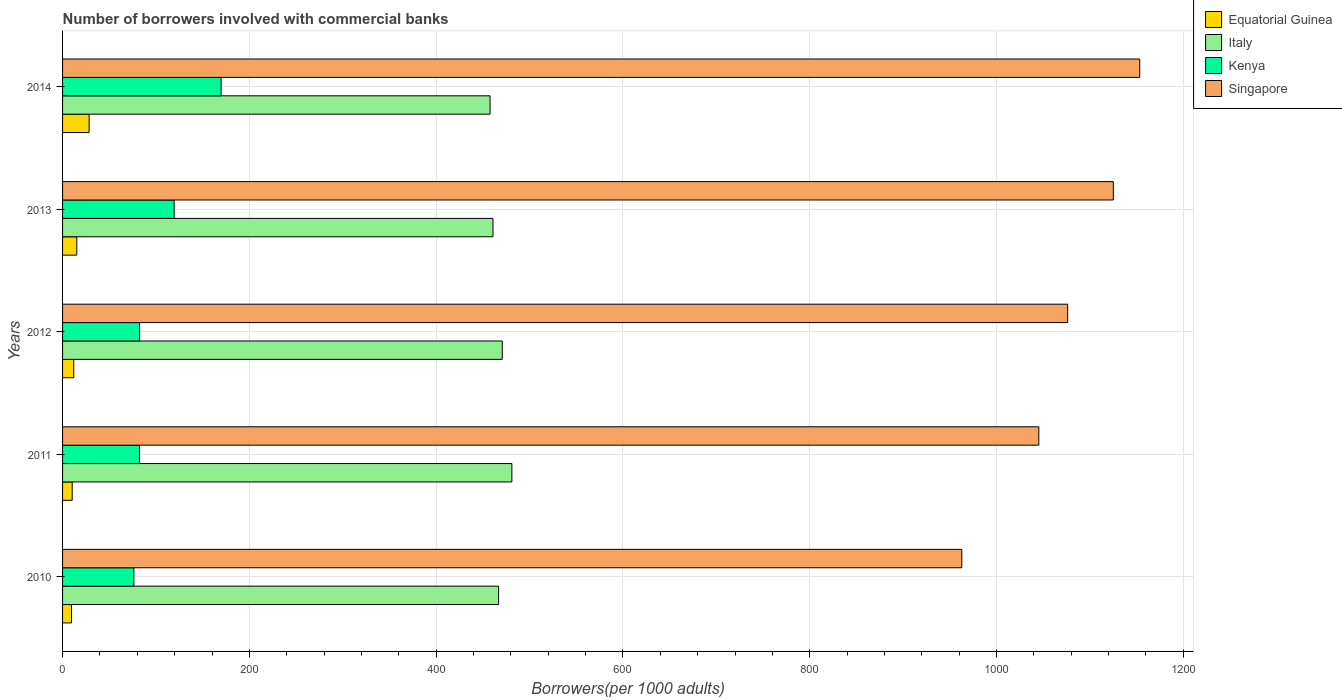How many different coloured bars are there?
Make the answer very short. 4. Are the number of bars per tick equal to the number of legend labels?
Keep it short and to the point. Yes. Are the number of bars on each tick of the Y-axis equal?
Provide a succinct answer. Yes. What is the number of borrowers involved with commercial banks in Singapore in 2014?
Offer a very short reply. 1153.3. Across all years, what is the maximum number of borrowers involved with commercial banks in Italy?
Give a very brief answer. 481.07. Across all years, what is the minimum number of borrowers involved with commercial banks in Italy?
Offer a terse response. 457.72. What is the total number of borrowers involved with commercial banks in Kenya in the graph?
Offer a very short reply. 530.31. What is the difference between the number of borrowers involved with commercial banks in Kenya in 2010 and that in 2014?
Offer a very short reply. -93.39. What is the difference between the number of borrowers involved with commercial banks in Kenya in 2014 and the number of borrowers involved with commercial banks in Italy in 2013?
Ensure brevity in your answer.  -291.11. What is the average number of borrowers involved with commercial banks in Equatorial Guinea per year?
Ensure brevity in your answer.  15.11. In the year 2014, what is the difference between the number of borrowers involved with commercial banks in Equatorial Guinea and number of borrowers involved with commercial banks in Kenya?
Offer a very short reply. -141.3. In how many years, is the number of borrowers involved with commercial banks in Italy greater than 920 ?
Keep it short and to the point. 0. What is the ratio of the number of borrowers involved with commercial banks in Equatorial Guinea in 2012 to that in 2014?
Your answer should be compact. 0.42. Is the difference between the number of borrowers involved with commercial banks in Equatorial Guinea in 2010 and 2012 greater than the difference between the number of borrowers involved with commercial banks in Kenya in 2010 and 2012?
Provide a short and direct response. Yes. What is the difference between the highest and the second highest number of borrowers involved with commercial banks in Italy?
Make the answer very short. 10.28. What is the difference between the highest and the lowest number of borrowers involved with commercial banks in Singapore?
Offer a terse response. 190.51. Is it the case that in every year, the sum of the number of borrowers involved with commercial banks in Equatorial Guinea and number of borrowers involved with commercial banks in Italy is greater than the sum of number of borrowers involved with commercial banks in Singapore and number of borrowers involved with commercial banks in Kenya?
Provide a short and direct response. Yes. What does the 2nd bar from the top in 2012 represents?
Provide a succinct answer. Kenya. What does the 2nd bar from the bottom in 2014 represents?
Provide a succinct answer. Italy. Is it the case that in every year, the sum of the number of borrowers involved with commercial banks in Kenya and number of borrowers involved with commercial banks in Singapore is greater than the number of borrowers involved with commercial banks in Equatorial Guinea?
Your response must be concise. Yes. How many bars are there?
Give a very brief answer. 20. How many years are there in the graph?
Provide a short and direct response. 5. What is the difference between two consecutive major ticks on the X-axis?
Make the answer very short. 200. Does the graph contain any zero values?
Keep it short and to the point. No. Does the graph contain grids?
Keep it short and to the point. Yes. How many legend labels are there?
Provide a succinct answer. 4. How are the legend labels stacked?
Your answer should be compact. Vertical. What is the title of the graph?
Keep it short and to the point. Number of borrowers involved with commercial banks. What is the label or title of the X-axis?
Provide a succinct answer. Borrowers(per 1000 adults). What is the Borrowers(per 1000 adults) of Equatorial Guinea in 2010?
Your answer should be compact. 9.58. What is the Borrowers(per 1000 adults) in Italy in 2010?
Your answer should be very brief. 466.85. What is the Borrowers(per 1000 adults) of Kenya in 2010?
Offer a very short reply. 76.34. What is the Borrowers(per 1000 adults) in Singapore in 2010?
Offer a terse response. 962.8. What is the Borrowers(per 1000 adults) of Equatorial Guinea in 2011?
Make the answer very short. 10.32. What is the Borrowers(per 1000 adults) of Italy in 2011?
Offer a terse response. 481.07. What is the Borrowers(per 1000 adults) of Kenya in 2011?
Make the answer very short. 82.34. What is the Borrowers(per 1000 adults) of Singapore in 2011?
Your answer should be very brief. 1045.25. What is the Borrowers(per 1000 adults) of Equatorial Guinea in 2012?
Provide a short and direct response. 11.98. What is the Borrowers(per 1000 adults) of Italy in 2012?
Offer a terse response. 470.79. What is the Borrowers(per 1000 adults) of Kenya in 2012?
Offer a very short reply. 82.45. What is the Borrowers(per 1000 adults) of Singapore in 2012?
Your answer should be very brief. 1076.16. What is the Borrowers(per 1000 adults) of Equatorial Guinea in 2013?
Your response must be concise. 15.22. What is the Borrowers(per 1000 adults) in Italy in 2013?
Provide a succinct answer. 460.84. What is the Borrowers(per 1000 adults) of Kenya in 2013?
Provide a short and direct response. 119.46. What is the Borrowers(per 1000 adults) in Singapore in 2013?
Keep it short and to the point. 1125.04. What is the Borrowers(per 1000 adults) in Equatorial Guinea in 2014?
Offer a terse response. 28.43. What is the Borrowers(per 1000 adults) of Italy in 2014?
Provide a succinct answer. 457.72. What is the Borrowers(per 1000 adults) in Kenya in 2014?
Provide a short and direct response. 169.73. What is the Borrowers(per 1000 adults) in Singapore in 2014?
Offer a terse response. 1153.3. Across all years, what is the maximum Borrowers(per 1000 adults) of Equatorial Guinea?
Make the answer very short. 28.43. Across all years, what is the maximum Borrowers(per 1000 adults) in Italy?
Provide a short and direct response. 481.07. Across all years, what is the maximum Borrowers(per 1000 adults) of Kenya?
Keep it short and to the point. 169.73. Across all years, what is the maximum Borrowers(per 1000 adults) of Singapore?
Give a very brief answer. 1153.3. Across all years, what is the minimum Borrowers(per 1000 adults) of Equatorial Guinea?
Make the answer very short. 9.58. Across all years, what is the minimum Borrowers(per 1000 adults) of Italy?
Your answer should be very brief. 457.72. Across all years, what is the minimum Borrowers(per 1000 adults) in Kenya?
Your answer should be compact. 76.34. Across all years, what is the minimum Borrowers(per 1000 adults) of Singapore?
Provide a short and direct response. 962.8. What is the total Borrowers(per 1000 adults) of Equatorial Guinea in the graph?
Ensure brevity in your answer.  75.53. What is the total Borrowers(per 1000 adults) of Italy in the graph?
Offer a very short reply. 2337.27. What is the total Borrowers(per 1000 adults) of Kenya in the graph?
Your response must be concise. 530.31. What is the total Borrowers(per 1000 adults) in Singapore in the graph?
Your answer should be very brief. 5362.55. What is the difference between the Borrowers(per 1000 adults) in Equatorial Guinea in 2010 and that in 2011?
Your response must be concise. -0.74. What is the difference between the Borrowers(per 1000 adults) in Italy in 2010 and that in 2011?
Your answer should be very brief. -14.22. What is the difference between the Borrowers(per 1000 adults) of Kenya in 2010 and that in 2011?
Your answer should be very brief. -6. What is the difference between the Borrowers(per 1000 adults) of Singapore in 2010 and that in 2011?
Make the answer very short. -82.46. What is the difference between the Borrowers(per 1000 adults) of Equatorial Guinea in 2010 and that in 2012?
Offer a terse response. -2.41. What is the difference between the Borrowers(per 1000 adults) in Italy in 2010 and that in 2012?
Offer a terse response. -3.94. What is the difference between the Borrowers(per 1000 adults) of Kenya in 2010 and that in 2012?
Offer a very short reply. -6.11. What is the difference between the Borrowers(per 1000 adults) of Singapore in 2010 and that in 2012?
Make the answer very short. -113.36. What is the difference between the Borrowers(per 1000 adults) in Equatorial Guinea in 2010 and that in 2013?
Offer a terse response. -5.64. What is the difference between the Borrowers(per 1000 adults) in Italy in 2010 and that in 2013?
Keep it short and to the point. 6.01. What is the difference between the Borrowers(per 1000 adults) of Kenya in 2010 and that in 2013?
Your answer should be compact. -43.12. What is the difference between the Borrowers(per 1000 adults) of Singapore in 2010 and that in 2013?
Your answer should be very brief. -162.25. What is the difference between the Borrowers(per 1000 adults) of Equatorial Guinea in 2010 and that in 2014?
Keep it short and to the point. -18.86. What is the difference between the Borrowers(per 1000 adults) in Italy in 2010 and that in 2014?
Provide a succinct answer. 9.13. What is the difference between the Borrowers(per 1000 adults) in Kenya in 2010 and that in 2014?
Provide a succinct answer. -93.39. What is the difference between the Borrowers(per 1000 adults) in Singapore in 2010 and that in 2014?
Your response must be concise. -190.51. What is the difference between the Borrowers(per 1000 adults) of Equatorial Guinea in 2011 and that in 2012?
Provide a succinct answer. -1.67. What is the difference between the Borrowers(per 1000 adults) of Italy in 2011 and that in 2012?
Ensure brevity in your answer.  10.28. What is the difference between the Borrowers(per 1000 adults) in Kenya in 2011 and that in 2012?
Keep it short and to the point. -0.11. What is the difference between the Borrowers(per 1000 adults) in Singapore in 2011 and that in 2012?
Your response must be concise. -30.9. What is the difference between the Borrowers(per 1000 adults) in Equatorial Guinea in 2011 and that in 2013?
Provide a short and direct response. -4.9. What is the difference between the Borrowers(per 1000 adults) of Italy in 2011 and that in 2013?
Keep it short and to the point. 20.23. What is the difference between the Borrowers(per 1000 adults) of Kenya in 2011 and that in 2013?
Give a very brief answer. -37.12. What is the difference between the Borrowers(per 1000 adults) in Singapore in 2011 and that in 2013?
Keep it short and to the point. -79.79. What is the difference between the Borrowers(per 1000 adults) of Equatorial Guinea in 2011 and that in 2014?
Provide a short and direct response. -18.12. What is the difference between the Borrowers(per 1000 adults) in Italy in 2011 and that in 2014?
Offer a very short reply. 23.35. What is the difference between the Borrowers(per 1000 adults) in Kenya in 2011 and that in 2014?
Provide a succinct answer. -87.39. What is the difference between the Borrowers(per 1000 adults) in Singapore in 2011 and that in 2014?
Offer a terse response. -108.05. What is the difference between the Borrowers(per 1000 adults) of Equatorial Guinea in 2012 and that in 2013?
Your answer should be compact. -3.23. What is the difference between the Borrowers(per 1000 adults) of Italy in 2012 and that in 2013?
Offer a very short reply. 9.95. What is the difference between the Borrowers(per 1000 adults) in Kenya in 2012 and that in 2013?
Make the answer very short. -37.01. What is the difference between the Borrowers(per 1000 adults) of Singapore in 2012 and that in 2013?
Provide a short and direct response. -48.89. What is the difference between the Borrowers(per 1000 adults) in Equatorial Guinea in 2012 and that in 2014?
Provide a short and direct response. -16.45. What is the difference between the Borrowers(per 1000 adults) in Italy in 2012 and that in 2014?
Offer a very short reply. 13.07. What is the difference between the Borrowers(per 1000 adults) in Kenya in 2012 and that in 2014?
Ensure brevity in your answer.  -87.28. What is the difference between the Borrowers(per 1000 adults) in Singapore in 2012 and that in 2014?
Ensure brevity in your answer.  -77.15. What is the difference between the Borrowers(per 1000 adults) in Equatorial Guinea in 2013 and that in 2014?
Provide a short and direct response. -13.22. What is the difference between the Borrowers(per 1000 adults) of Italy in 2013 and that in 2014?
Keep it short and to the point. 3.12. What is the difference between the Borrowers(per 1000 adults) of Kenya in 2013 and that in 2014?
Keep it short and to the point. -50.27. What is the difference between the Borrowers(per 1000 adults) of Singapore in 2013 and that in 2014?
Give a very brief answer. -28.26. What is the difference between the Borrowers(per 1000 adults) of Equatorial Guinea in 2010 and the Borrowers(per 1000 adults) of Italy in 2011?
Provide a short and direct response. -471.49. What is the difference between the Borrowers(per 1000 adults) of Equatorial Guinea in 2010 and the Borrowers(per 1000 adults) of Kenya in 2011?
Ensure brevity in your answer.  -72.76. What is the difference between the Borrowers(per 1000 adults) of Equatorial Guinea in 2010 and the Borrowers(per 1000 adults) of Singapore in 2011?
Ensure brevity in your answer.  -1035.67. What is the difference between the Borrowers(per 1000 adults) of Italy in 2010 and the Borrowers(per 1000 adults) of Kenya in 2011?
Offer a very short reply. 384.51. What is the difference between the Borrowers(per 1000 adults) in Italy in 2010 and the Borrowers(per 1000 adults) in Singapore in 2011?
Your answer should be compact. -578.4. What is the difference between the Borrowers(per 1000 adults) in Kenya in 2010 and the Borrowers(per 1000 adults) in Singapore in 2011?
Provide a short and direct response. -968.91. What is the difference between the Borrowers(per 1000 adults) of Equatorial Guinea in 2010 and the Borrowers(per 1000 adults) of Italy in 2012?
Keep it short and to the point. -461.21. What is the difference between the Borrowers(per 1000 adults) in Equatorial Guinea in 2010 and the Borrowers(per 1000 adults) in Kenya in 2012?
Make the answer very short. -72.87. What is the difference between the Borrowers(per 1000 adults) in Equatorial Guinea in 2010 and the Borrowers(per 1000 adults) in Singapore in 2012?
Offer a very short reply. -1066.58. What is the difference between the Borrowers(per 1000 adults) in Italy in 2010 and the Borrowers(per 1000 adults) in Kenya in 2012?
Ensure brevity in your answer.  384.4. What is the difference between the Borrowers(per 1000 adults) in Italy in 2010 and the Borrowers(per 1000 adults) in Singapore in 2012?
Offer a terse response. -609.31. What is the difference between the Borrowers(per 1000 adults) of Kenya in 2010 and the Borrowers(per 1000 adults) of Singapore in 2012?
Offer a very short reply. -999.82. What is the difference between the Borrowers(per 1000 adults) of Equatorial Guinea in 2010 and the Borrowers(per 1000 adults) of Italy in 2013?
Provide a short and direct response. -451.26. What is the difference between the Borrowers(per 1000 adults) in Equatorial Guinea in 2010 and the Borrowers(per 1000 adults) in Kenya in 2013?
Your response must be concise. -109.88. What is the difference between the Borrowers(per 1000 adults) of Equatorial Guinea in 2010 and the Borrowers(per 1000 adults) of Singapore in 2013?
Ensure brevity in your answer.  -1115.46. What is the difference between the Borrowers(per 1000 adults) of Italy in 2010 and the Borrowers(per 1000 adults) of Kenya in 2013?
Make the answer very short. 347.39. What is the difference between the Borrowers(per 1000 adults) in Italy in 2010 and the Borrowers(per 1000 adults) in Singapore in 2013?
Provide a short and direct response. -658.19. What is the difference between the Borrowers(per 1000 adults) of Kenya in 2010 and the Borrowers(per 1000 adults) of Singapore in 2013?
Provide a succinct answer. -1048.7. What is the difference between the Borrowers(per 1000 adults) in Equatorial Guinea in 2010 and the Borrowers(per 1000 adults) in Italy in 2014?
Offer a terse response. -448.15. What is the difference between the Borrowers(per 1000 adults) of Equatorial Guinea in 2010 and the Borrowers(per 1000 adults) of Kenya in 2014?
Offer a very short reply. -160.15. What is the difference between the Borrowers(per 1000 adults) in Equatorial Guinea in 2010 and the Borrowers(per 1000 adults) in Singapore in 2014?
Your answer should be compact. -1143.73. What is the difference between the Borrowers(per 1000 adults) in Italy in 2010 and the Borrowers(per 1000 adults) in Kenya in 2014?
Offer a very short reply. 297.12. What is the difference between the Borrowers(per 1000 adults) of Italy in 2010 and the Borrowers(per 1000 adults) of Singapore in 2014?
Your response must be concise. -686.45. What is the difference between the Borrowers(per 1000 adults) of Kenya in 2010 and the Borrowers(per 1000 adults) of Singapore in 2014?
Make the answer very short. -1076.96. What is the difference between the Borrowers(per 1000 adults) of Equatorial Guinea in 2011 and the Borrowers(per 1000 adults) of Italy in 2012?
Ensure brevity in your answer.  -460.47. What is the difference between the Borrowers(per 1000 adults) of Equatorial Guinea in 2011 and the Borrowers(per 1000 adults) of Kenya in 2012?
Provide a succinct answer. -72.13. What is the difference between the Borrowers(per 1000 adults) of Equatorial Guinea in 2011 and the Borrowers(per 1000 adults) of Singapore in 2012?
Keep it short and to the point. -1065.84. What is the difference between the Borrowers(per 1000 adults) in Italy in 2011 and the Borrowers(per 1000 adults) in Kenya in 2012?
Offer a very short reply. 398.62. What is the difference between the Borrowers(per 1000 adults) of Italy in 2011 and the Borrowers(per 1000 adults) of Singapore in 2012?
Provide a succinct answer. -595.09. What is the difference between the Borrowers(per 1000 adults) of Kenya in 2011 and the Borrowers(per 1000 adults) of Singapore in 2012?
Your answer should be compact. -993.82. What is the difference between the Borrowers(per 1000 adults) of Equatorial Guinea in 2011 and the Borrowers(per 1000 adults) of Italy in 2013?
Your answer should be very brief. -450.52. What is the difference between the Borrowers(per 1000 adults) in Equatorial Guinea in 2011 and the Borrowers(per 1000 adults) in Kenya in 2013?
Provide a succinct answer. -109.14. What is the difference between the Borrowers(per 1000 adults) in Equatorial Guinea in 2011 and the Borrowers(per 1000 adults) in Singapore in 2013?
Provide a short and direct response. -1114.72. What is the difference between the Borrowers(per 1000 adults) in Italy in 2011 and the Borrowers(per 1000 adults) in Kenya in 2013?
Give a very brief answer. 361.61. What is the difference between the Borrowers(per 1000 adults) of Italy in 2011 and the Borrowers(per 1000 adults) of Singapore in 2013?
Offer a very short reply. -643.97. What is the difference between the Borrowers(per 1000 adults) of Kenya in 2011 and the Borrowers(per 1000 adults) of Singapore in 2013?
Offer a terse response. -1042.71. What is the difference between the Borrowers(per 1000 adults) in Equatorial Guinea in 2011 and the Borrowers(per 1000 adults) in Italy in 2014?
Provide a succinct answer. -447.41. What is the difference between the Borrowers(per 1000 adults) of Equatorial Guinea in 2011 and the Borrowers(per 1000 adults) of Kenya in 2014?
Make the answer very short. -159.41. What is the difference between the Borrowers(per 1000 adults) of Equatorial Guinea in 2011 and the Borrowers(per 1000 adults) of Singapore in 2014?
Ensure brevity in your answer.  -1142.99. What is the difference between the Borrowers(per 1000 adults) of Italy in 2011 and the Borrowers(per 1000 adults) of Kenya in 2014?
Your answer should be compact. 311.34. What is the difference between the Borrowers(per 1000 adults) of Italy in 2011 and the Borrowers(per 1000 adults) of Singapore in 2014?
Provide a short and direct response. -672.23. What is the difference between the Borrowers(per 1000 adults) in Kenya in 2011 and the Borrowers(per 1000 adults) in Singapore in 2014?
Offer a very short reply. -1070.97. What is the difference between the Borrowers(per 1000 adults) of Equatorial Guinea in 2012 and the Borrowers(per 1000 adults) of Italy in 2013?
Provide a short and direct response. -448.86. What is the difference between the Borrowers(per 1000 adults) of Equatorial Guinea in 2012 and the Borrowers(per 1000 adults) of Kenya in 2013?
Make the answer very short. -107.48. What is the difference between the Borrowers(per 1000 adults) of Equatorial Guinea in 2012 and the Borrowers(per 1000 adults) of Singapore in 2013?
Your response must be concise. -1113.06. What is the difference between the Borrowers(per 1000 adults) of Italy in 2012 and the Borrowers(per 1000 adults) of Kenya in 2013?
Your response must be concise. 351.33. What is the difference between the Borrowers(per 1000 adults) in Italy in 2012 and the Borrowers(per 1000 adults) in Singapore in 2013?
Ensure brevity in your answer.  -654.25. What is the difference between the Borrowers(per 1000 adults) in Kenya in 2012 and the Borrowers(per 1000 adults) in Singapore in 2013?
Ensure brevity in your answer.  -1042.6. What is the difference between the Borrowers(per 1000 adults) in Equatorial Guinea in 2012 and the Borrowers(per 1000 adults) in Italy in 2014?
Your answer should be compact. -445.74. What is the difference between the Borrowers(per 1000 adults) of Equatorial Guinea in 2012 and the Borrowers(per 1000 adults) of Kenya in 2014?
Ensure brevity in your answer.  -157.75. What is the difference between the Borrowers(per 1000 adults) of Equatorial Guinea in 2012 and the Borrowers(per 1000 adults) of Singapore in 2014?
Keep it short and to the point. -1141.32. What is the difference between the Borrowers(per 1000 adults) of Italy in 2012 and the Borrowers(per 1000 adults) of Kenya in 2014?
Give a very brief answer. 301.06. What is the difference between the Borrowers(per 1000 adults) in Italy in 2012 and the Borrowers(per 1000 adults) in Singapore in 2014?
Offer a terse response. -682.51. What is the difference between the Borrowers(per 1000 adults) in Kenya in 2012 and the Borrowers(per 1000 adults) in Singapore in 2014?
Provide a short and direct response. -1070.86. What is the difference between the Borrowers(per 1000 adults) of Equatorial Guinea in 2013 and the Borrowers(per 1000 adults) of Italy in 2014?
Your answer should be very brief. -442.51. What is the difference between the Borrowers(per 1000 adults) in Equatorial Guinea in 2013 and the Borrowers(per 1000 adults) in Kenya in 2014?
Provide a short and direct response. -154.52. What is the difference between the Borrowers(per 1000 adults) of Equatorial Guinea in 2013 and the Borrowers(per 1000 adults) of Singapore in 2014?
Ensure brevity in your answer.  -1138.09. What is the difference between the Borrowers(per 1000 adults) in Italy in 2013 and the Borrowers(per 1000 adults) in Kenya in 2014?
Your answer should be compact. 291.11. What is the difference between the Borrowers(per 1000 adults) of Italy in 2013 and the Borrowers(per 1000 adults) of Singapore in 2014?
Keep it short and to the point. -692.46. What is the difference between the Borrowers(per 1000 adults) of Kenya in 2013 and the Borrowers(per 1000 adults) of Singapore in 2014?
Make the answer very short. -1033.84. What is the average Borrowers(per 1000 adults) of Equatorial Guinea per year?
Your answer should be very brief. 15.11. What is the average Borrowers(per 1000 adults) in Italy per year?
Provide a short and direct response. 467.45. What is the average Borrowers(per 1000 adults) of Kenya per year?
Provide a succinct answer. 106.06. What is the average Borrowers(per 1000 adults) of Singapore per year?
Your response must be concise. 1072.51. In the year 2010, what is the difference between the Borrowers(per 1000 adults) of Equatorial Guinea and Borrowers(per 1000 adults) of Italy?
Keep it short and to the point. -457.27. In the year 2010, what is the difference between the Borrowers(per 1000 adults) of Equatorial Guinea and Borrowers(per 1000 adults) of Kenya?
Ensure brevity in your answer.  -66.76. In the year 2010, what is the difference between the Borrowers(per 1000 adults) of Equatorial Guinea and Borrowers(per 1000 adults) of Singapore?
Your answer should be compact. -953.22. In the year 2010, what is the difference between the Borrowers(per 1000 adults) of Italy and Borrowers(per 1000 adults) of Kenya?
Offer a terse response. 390.51. In the year 2010, what is the difference between the Borrowers(per 1000 adults) of Italy and Borrowers(per 1000 adults) of Singapore?
Provide a short and direct response. -495.95. In the year 2010, what is the difference between the Borrowers(per 1000 adults) in Kenya and Borrowers(per 1000 adults) in Singapore?
Provide a succinct answer. -886.46. In the year 2011, what is the difference between the Borrowers(per 1000 adults) of Equatorial Guinea and Borrowers(per 1000 adults) of Italy?
Provide a succinct answer. -470.75. In the year 2011, what is the difference between the Borrowers(per 1000 adults) in Equatorial Guinea and Borrowers(per 1000 adults) in Kenya?
Your answer should be very brief. -72.02. In the year 2011, what is the difference between the Borrowers(per 1000 adults) of Equatorial Guinea and Borrowers(per 1000 adults) of Singapore?
Your response must be concise. -1034.93. In the year 2011, what is the difference between the Borrowers(per 1000 adults) in Italy and Borrowers(per 1000 adults) in Kenya?
Your response must be concise. 398.73. In the year 2011, what is the difference between the Borrowers(per 1000 adults) in Italy and Borrowers(per 1000 adults) in Singapore?
Offer a terse response. -564.18. In the year 2011, what is the difference between the Borrowers(per 1000 adults) in Kenya and Borrowers(per 1000 adults) in Singapore?
Ensure brevity in your answer.  -962.92. In the year 2012, what is the difference between the Borrowers(per 1000 adults) of Equatorial Guinea and Borrowers(per 1000 adults) of Italy?
Ensure brevity in your answer.  -458.8. In the year 2012, what is the difference between the Borrowers(per 1000 adults) of Equatorial Guinea and Borrowers(per 1000 adults) of Kenya?
Provide a succinct answer. -70.46. In the year 2012, what is the difference between the Borrowers(per 1000 adults) in Equatorial Guinea and Borrowers(per 1000 adults) in Singapore?
Offer a terse response. -1064.17. In the year 2012, what is the difference between the Borrowers(per 1000 adults) of Italy and Borrowers(per 1000 adults) of Kenya?
Ensure brevity in your answer.  388.34. In the year 2012, what is the difference between the Borrowers(per 1000 adults) of Italy and Borrowers(per 1000 adults) of Singapore?
Your answer should be very brief. -605.37. In the year 2012, what is the difference between the Borrowers(per 1000 adults) in Kenya and Borrowers(per 1000 adults) in Singapore?
Give a very brief answer. -993.71. In the year 2013, what is the difference between the Borrowers(per 1000 adults) of Equatorial Guinea and Borrowers(per 1000 adults) of Italy?
Ensure brevity in your answer.  -445.62. In the year 2013, what is the difference between the Borrowers(per 1000 adults) of Equatorial Guinea and Borrowers(per 1000 adults) of Kenya?
Keep it short and to the point. -104.25. In the year 2013, what is the difference between the Borrowers(per 1000 adults) in Equatorial Guinea and Borrowers(per 1000 adults) in Singapore?
Ensure brevity in your answer.  -1109.83. In the year 2013, what is the difference between the Borrowers(per 1000 adults) of Italy and Borrowers(per 1000 adults) of Kenya?
Your answer should be very brief. 341.38. In the year 2013, what is the difference between the Borrowers(per 1000 adults) of Italy and Borrowers(per 1000 adults) of Singapore?
Offer a terse response. -664.2. In the year 2013, what is the difference between the Borrowers(per 1000 adults) in Kenya and Borrowers(per 1000 adults) in Singapore?
Your answer should be very brief. -1005.58. In the year 2014, what is the difference between the Borrowers(per 1000 adults) in Equatorial Guinea and Borrowers(per 1000 adults) in Italy?
Provide a short and direct response. -429.29. In the year 2014, what is the difference between the Borrowers(per 1000 adults) in Equatorial Guinea and Borrowers(per 1000 adults) in Kenya?
Offer a very short reply. -141.3. In the year 2014, what is the difference between the Borrowers(per 1000 adults) in Equatorial Guinea and Borrowers(per 1000 adults) in Singapore?
Your response must be concise. -1124.87. In the year 2014, what is the difference between the Borrowers(per 1000 adults) of Italy and Borrowers(per 1000 adults) of Kenya?
Give a very brief answer. 287.99. In the year 2014, what is the difference between the Borrowers(per 1000 adults) of Italy and Borrowers(per 1000 adults) of Singapore?
Ensure brevity in your answer.  -695.58. In the year 2014, what is the difference between the Borrowers(per 1000 adults) in Kenya and Borrowers(per 1000 adults) in Singapore?
Offer a very short reply. -983.57. What is the ratio of the Borrowers(per 1000 adults) of Equatorial Guinea in 2010 to that in 2011?
Provide a short and direct response. 0.93. What is the ratio of the Borrowers(per 1000 adults) of Italy in 2010 to that in 2011?
Your response must be concise. 0.97. What is the ratio of the Borrowers(per 1000 adults) of Kenya in 2010 to that in 2011?
Provide a succinct answer. 0.93. What is the ratio of the Borrowers(per 1000 adults) in Singapore in 2010 to that in 2011?
Your answer should be compact. 0.92. What is the ratio of the Borrowers(per 1000 adults) in Equatorial Guinea in 2010 to that in 2012?
Your answer should be very brief. 0.8. What is the ratio of the Borrowers(per 1000 adults) of Kenya in 2010 to that in 2012?
Your answer should be compact. 0.93. What is the ratio of the Borrowers(per 1000 adults) in Singapore in 2010 to that in 2012?
Make the answer very short. 0.89. What is the ratio of the Borrowers(per 1000 adults) in Equatorial Guinea in 2010 to that in 2013?
Your response must be concise. 0.63. What is the ratio of the Borrowers(per 1000 adults) of Italy in 2010 to that in 2013?
Offer a terse response. 1.01. What is the ratio of the Borrowers(per 1000 adults) of Kenya in 2010 to that in 2013?
Provide a succinct answer. 0.64. What is the ratio of the Borrowers(per 1000 adults) of Singapore in 2010 to that in 2013?
Offer a very short reply. 0.86. What is the ratio of the Borrowers(per 1000 adults) of Equatorial Guinea in 2010 to that in 2014?
Give a very brief answer. 0.34. What is the ratio of the Borrowers(per 1000 adults) in Italy in 2010 to that in 2014?
Offer a terse response. 1.02. What is the ratio of the Borrowers(per 1000 adults) in Kenya in 2010 to that in 2014?
Provide a succinct answer. 0.45. What is the ratio of the Borrowers(per 1000 adults) in Singapore in 2010 to that in 2014?
Give a very brief answer. 0.83. What is the ratio of the Borrowers(per 1000 adults) of Equatorial Guinea in 2011 to that in 2012?
Make the answer very short. 0.86. What is the ratio of the Borrowers(per 1000 adults) in Italy in 2011 to that in 2012?
Offer a very short reply. 1.02. What is the ratio of the Borrowers(per 1000 adults) in Singapore in 2011 to that in 2012?
Ensure brevity in your answer.  0.97. What is the ratio of the Borrowers(per 1000 adults) of Equatorial Guinea in 2011 to that in 2013?
Provide a succinct answer. 0.68. What is the ratio of the Borrowers(per 1000 adults) in Italy in 2011 to that in 2013?
Make the answer very short. 1.04. What is the ratio of the Borrowers(per 1000 adults) of Kenya in 2011 to that in 2013?
Ensure brevity in your answer.  0.69. What is the ratio of the Borrowers(per 1000 adults) of Singapore in 2011 to that in 2013?
Keep it short and to the point. 0.93. What is the ratio of the Borrowers(per 1000 adults) of Equatorial Guinea in 2011 to that in 2014?
Your answer should be very brief. 0.36. What is the ratio of the Borrowers(per 1000 adults) in Italy in 2011 to that in 2014?
Ensure brevity in your answer.  1.05. What is the ratio of the Borrowers(per 1000 adults) of Kenya in 2011 to that in 2014?
Your answer should be compact. 0.49. What is the ratio of the Borrowers(per 1000 adults) in Singapore in 2011 to that in 2014?
Give a very brief answer. 0.91. What is the ratio of the Borrowers(per 1000 adults) in Equatorial Guinea in 2012 to that in 2013?
Provide a short and direct response. 0.79. What is the ratio of the Borrowers(per 1000 adults) in Italy in 2012 to that in 2013?
Give a very brief answer. 1.02. What is the ratio of the Borrowers(per 1000 adults) of Kenya in 2012 to that in 2013?
Provide a short and direct response. 0.69. What is the ratio of the Borrowers(per 1000 adults) in Singapore in 2012 to that in 2013?
Offer a very short reply. 0.96. What is the ratio of the Borrowers(per 1000 adults) of Equatorial Guinea in 2012 to that in 2014?
Your answer should be very brief. 0.42. What is the ratio of the Borrowers(per 1000 adults) of Italy in 2012 to that in 2014?
Your answer should be very brief. 1.03. What is the ratio of the Borrowers(per 1000 adults) of Kenya in 2012 to that in 2014?
Ensure brevity in your answer.  0.49. What is the ratio of the Borrowers(per 1000 adults) in Singapore in 2012 to that in 2014?
Provide a short and direct response. 0.93. What is the ratio of the Borrowers(per 1000 adults) of Equatorial Guinea in 2013 to that in 2014?
Keep it short and to the point. 0.54. What is the ratio of the Borrowers(per 1000 adults) of Italy in 2013 to that in 2014?
Give a very brief answer. 1.01. What is the ratio of the Borrowers(per 1000 adults) of Kenya in 2013 to that in 2014?
Your answer should be very brief. 0.7. What is the ratio of the Borrowers(per 1000 adults) of Singapore in 2013 to that in 2014?
Offer a terse response. 0.98. What is the difference between the highest and the second highest Borrowers(per 1000 adults) of Equatorial Guinea?
Your answer should be compact. 13.22. What is the difference between the highest and the second highest Borrowers(per 1000 adults) of Italy?
Make the answer very short. 10.28. What is the difference between the highest and the second highest Borrowers(per 1000 adults) in Kenya?
Make the answer very short. 50.27. What is the difference between the highest and the second highest Borrowers(per 1000 adults) of Singapore?
Your response must be concise. 28.26. What is the difference between the highest and the lowest Borrowers(per 1000 adults) of Equatorial Guinea?
Make the answer very short. 18.86. What is the difference between the highest and the lowest Borrowers(per 1000 adults) in Italy?
Provide a succinct answer. 23.35. What is the difference between the highest and the lowest Borrowers(per 1000 adults) in Kenya?
Offer a terse response. 93.39. What is the difference between the highest and the lowest Borrowers(per 1000 adults) in Singapore?
Provide a succinct answer. 190.51. 